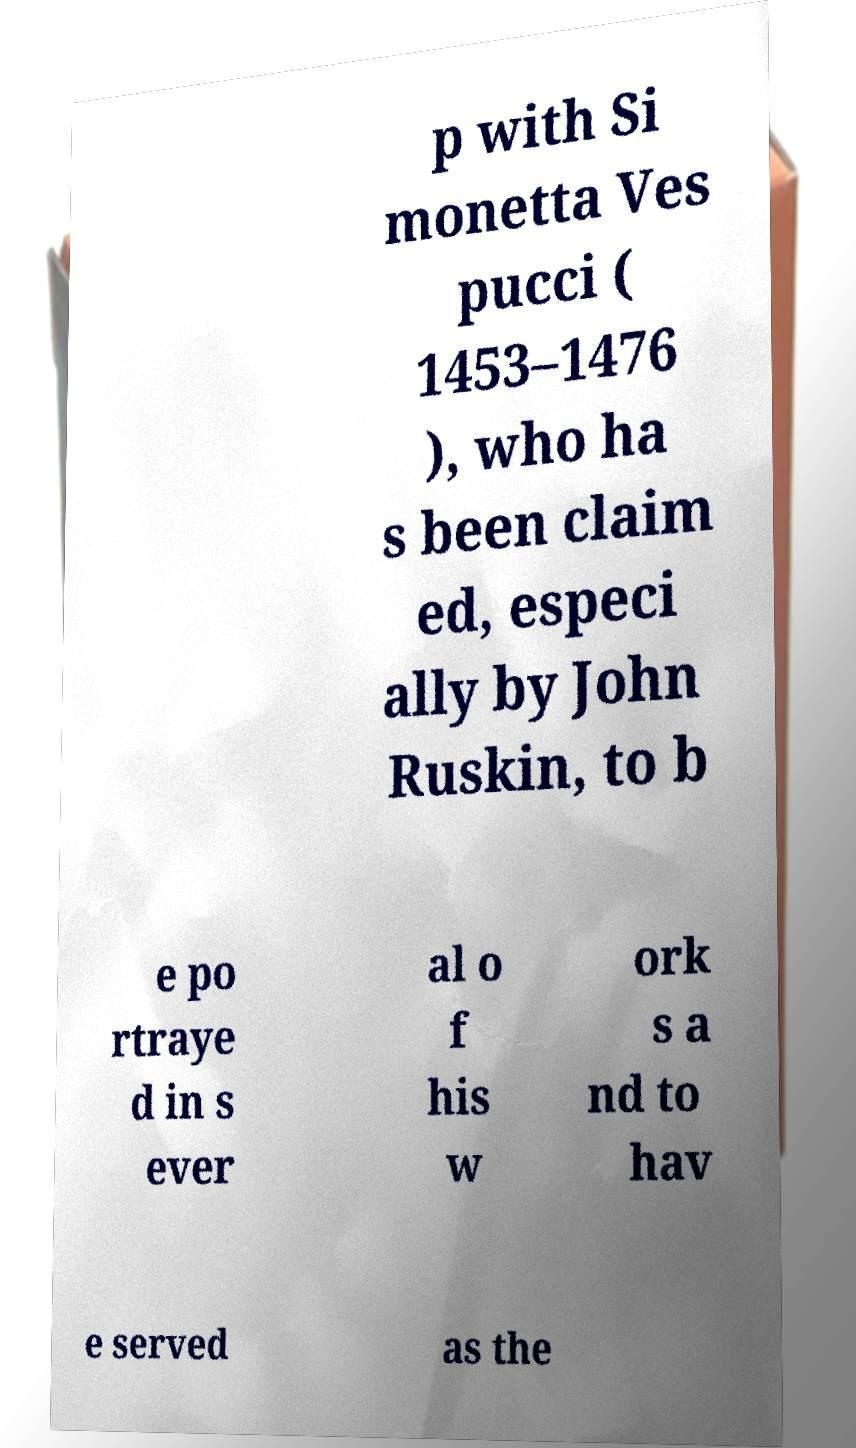Could you assist in decoding the text presented in this image and type it out clearly? p with Si monetta Ves pucci ( 1453–1476 ), who ha s been claim ed, especi ally by John Ruskin, to b e po rtraye d in s ever al o f his w ork s a nd to hav e served as the 